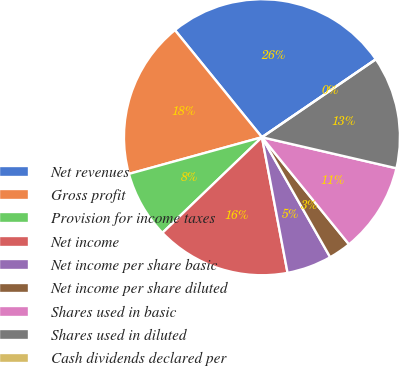Convert chart to OTSL. <chart><loc_0><loc_0><loc_500><loc_500><pie_chart><fcel>Net revenues<fcel>Gross profit<fcel>Provision for income taxes<fcel>Net income<fcel>Net income per share basic<fcel>Net income per share diluted<fcel>Shares used in basic<fcel>Shares used in diluted<fcel>Cash dividends declared per<nl><fcel>26.31%<fcel>18.42%<fcel>7.9%<fcel>15.79%<fcel>5.26%<fcel>2.63%<fcel>10.53%<fcel>13.16%<fcel>0.0%<nl></chart> 